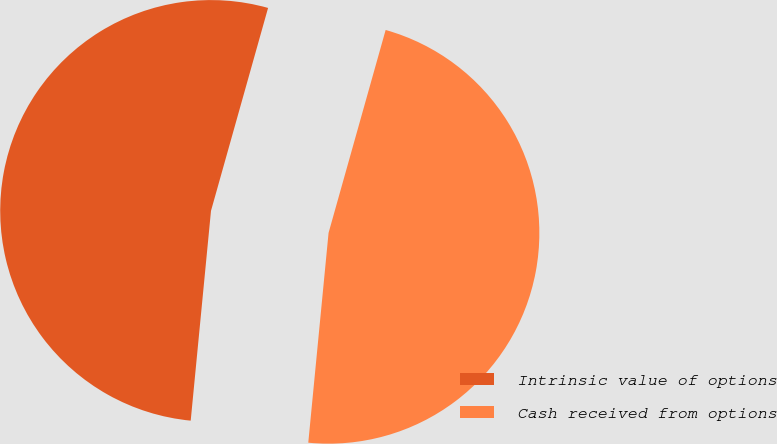Convert chart. <chart><loc_0><loc_0><loc_500><loc_500><pie_chart><fcel>Intrinsic value of options<fcel>Cash received from options<nl><fcel>52.83%<fcel>47.17%<nl></chart> 